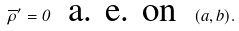<formula> <loc_0><loc_0><loc_500><loc_500>\overline { \rho } ^ { \prime } = 0 \ \text { a. e. on } \ ( a , b ) .</formula> 